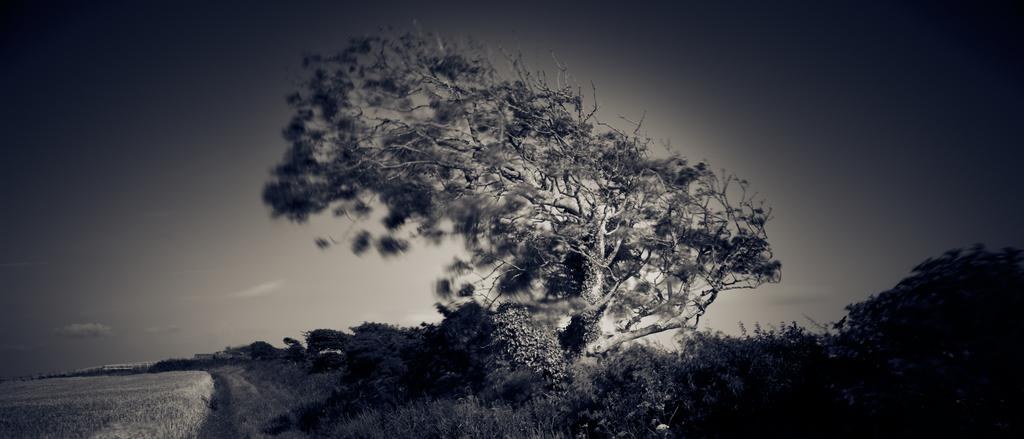What type of vegetation is the main subject in the image? There is a big tree in the image. What can be seen at the bottom of the image? Grass and plants are visible at the bottom of the image. What type of landscape is on the left side of the image? There is a farmland on the left side of the image. What is visible at the top of the image? The sky is visible at the top of the image. What can be seen in the sky? Clouds are present in the sky. Where is the clock located in the image? There is no clock present in the image. What type of base supports the bridge in the image? There is no bridge present in the image. 